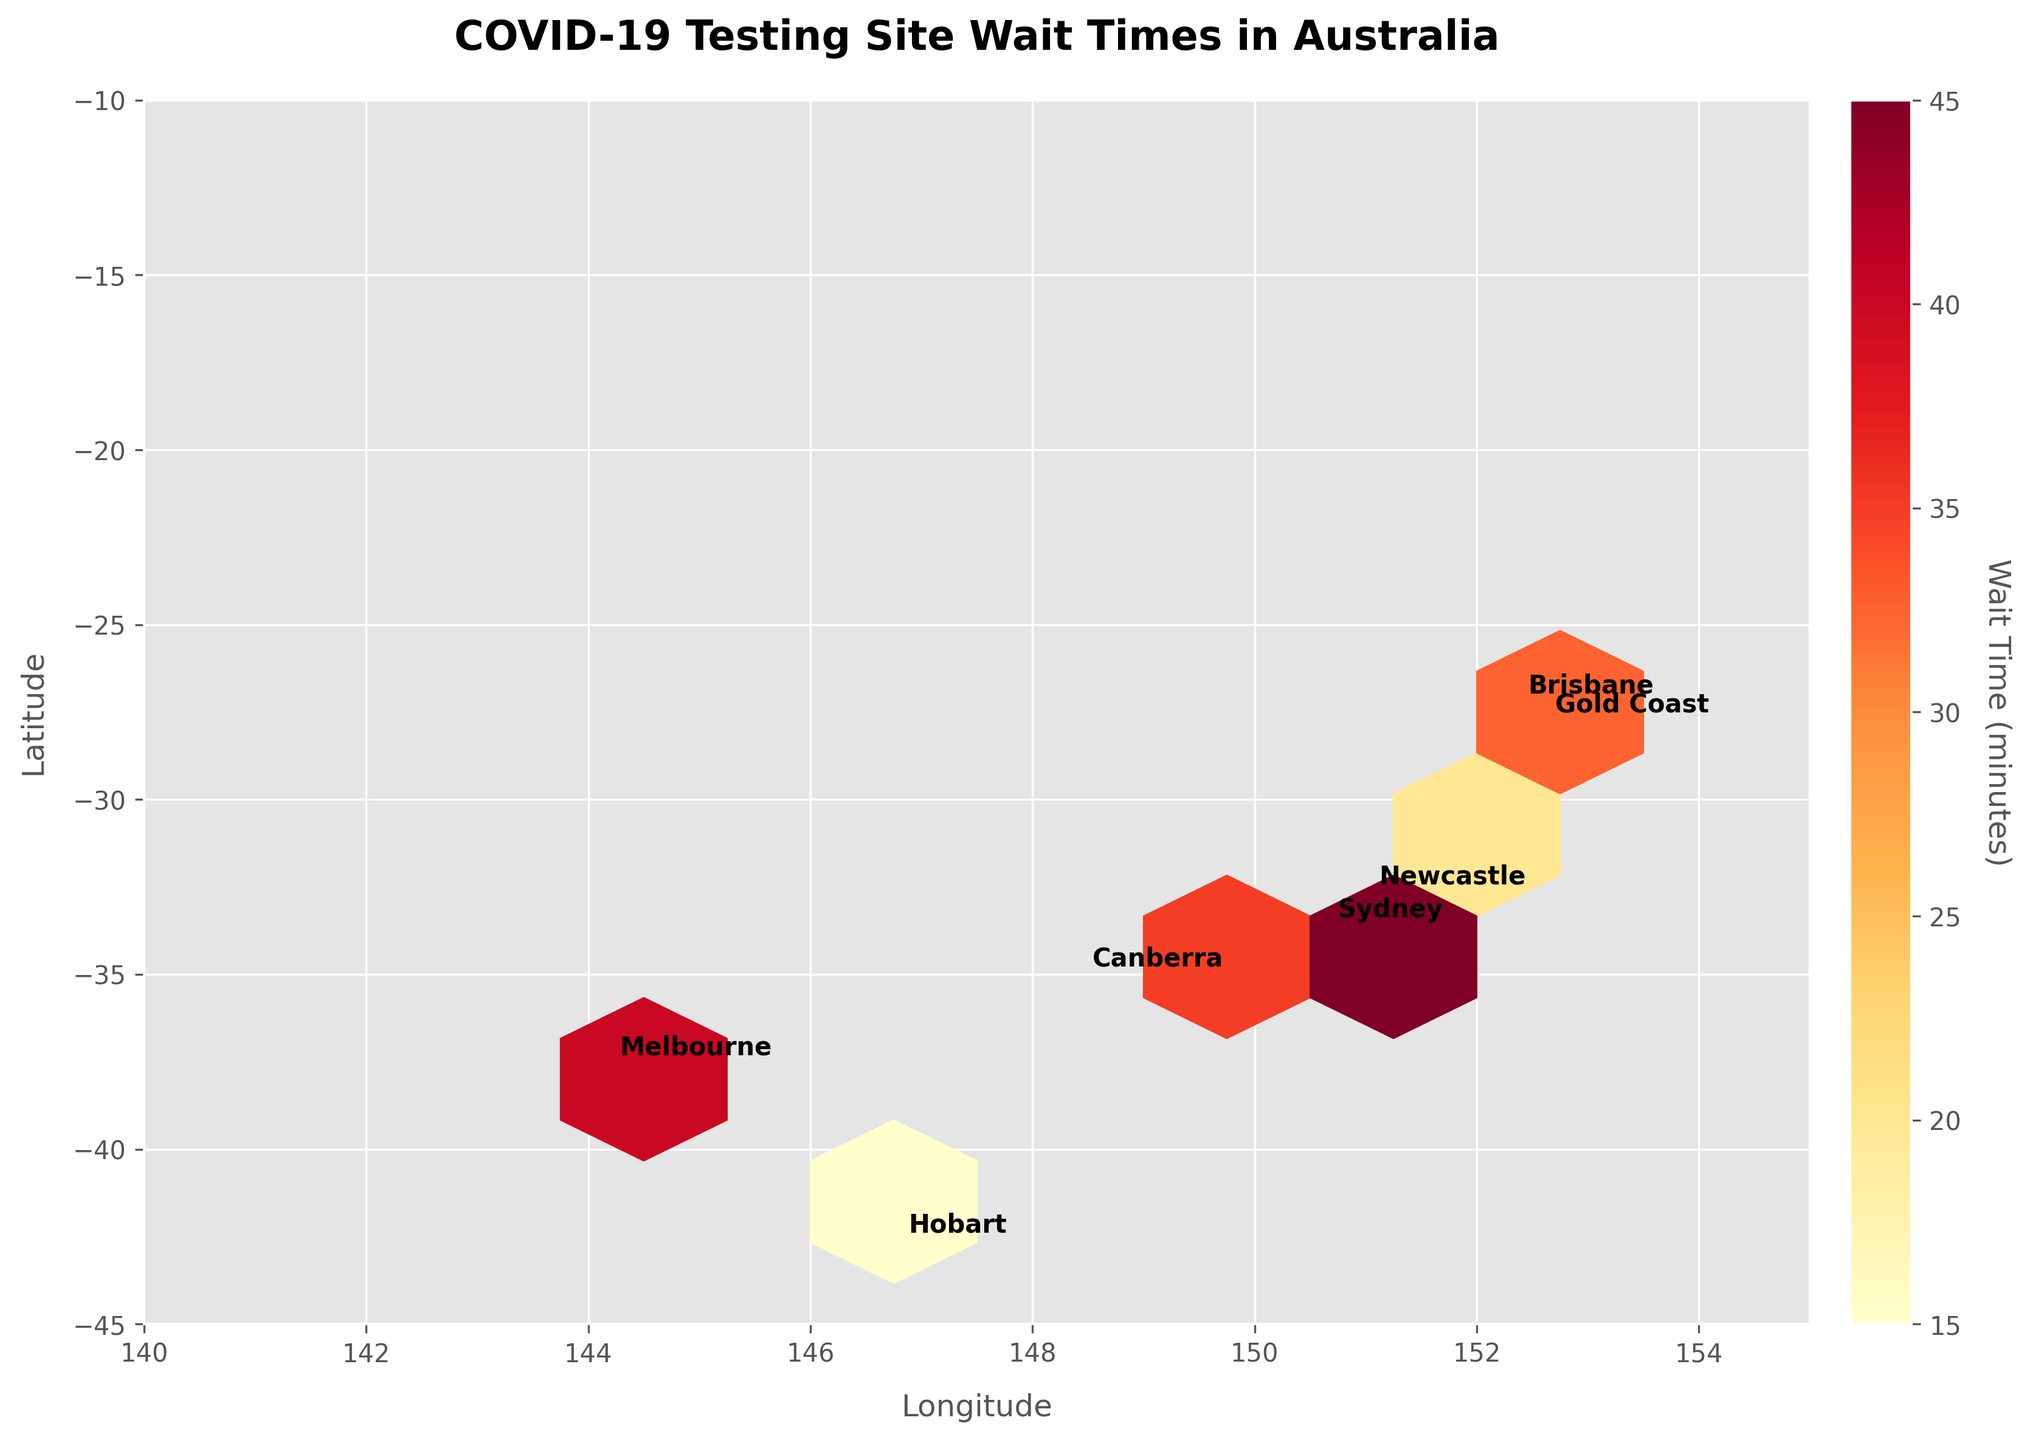What's the title of the figure? The title is typically located at the top of the plot and is designed to summarize the content of the visual representation. In this case, the title is meant to indicate what the Hexbin Plot is about.
Answer: COVID-19 Testing Site Wait Times in Australia What does the color in the plot represent? In a Hexbin Plot, color is used to represent a specific variable of interest. Here, the color indicates the wait times at COVID-19 testing sites.
Answer: Wait times (minutes) Which city has the highest average wait time for COVID-19 testing sites? To identify the city with the highest average wait time, one must look at the hexagons' color intensities near each city's annotation. The deepest or most intense color corresponds to the longest wait time.
Answer: Sydney Are there any cities with very low wait times? If so, which ones? By observing the color scale and matching it with the plot, low wait times are indicated by the lightest colors. Look for cities where the hexagons are light-colored.
Answer: Darwin and Hobart Which cities have similar average wait times for their testing sites? Look for cities that have hexagons with similar color shades. This suggests that the average wait times do not differ much.
Answer: Brisbane and Canberra What city shows the largest variance in wait times at COVID-19 testing sites? Variance is inferred from the range of colors in a hexbin plot section. The city with varying shades (light to dark) in its region has the largest variance.
Answer: Sydney Which side of Australia seems to have generally lower wait times, the eastern or the western side? Observe the overall color intensity on each side of the plot. The side with lighter hexagons overall has lower wait times.
Answer: Western side How do wait times in Sydney compare to those in Melbourne? Compare the hexagon colors around Sydney's average position with those around Melbourne's.
Answer: Sydney has generally higher wait times than Melbourne What's the average position used for annotating the cities? The position for annotation is based on calculating the mean longitude and latitude for each city's data points.
Answer: Mean longitude and latitude Which parts of Australia, according to the plot, have the densest grouping of testing sites? The density of points is indicated by how crowded the hexagons are in a certain area. More hexagons closer together mean a denser grouping.
Answer: Eastern Australia, notably Sydney and Melbourne 